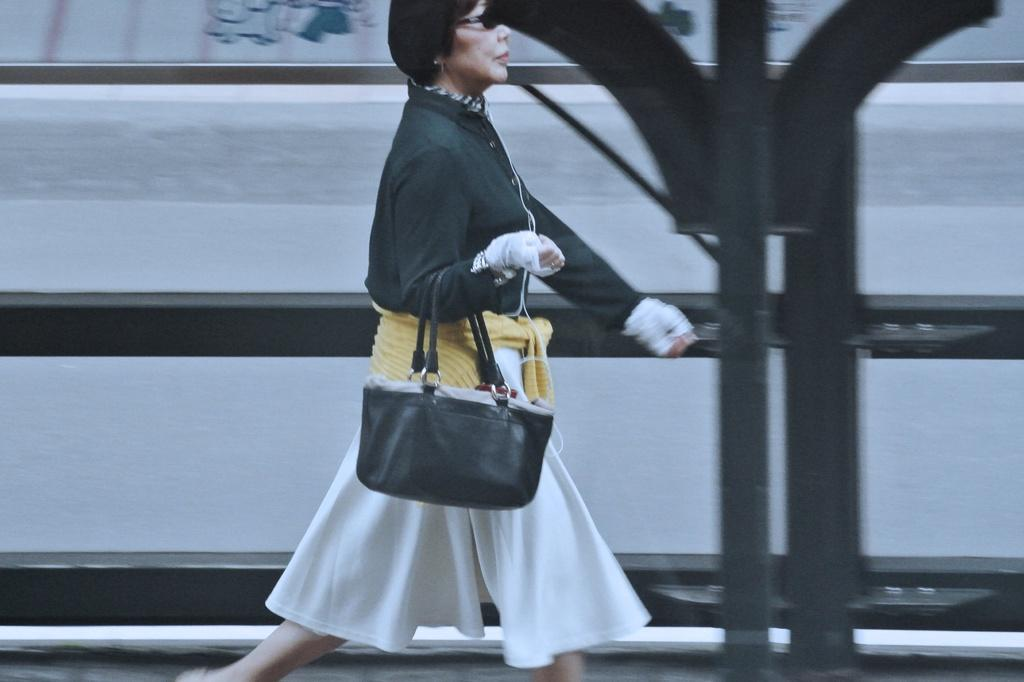Who is the main subject in the image? There is a woman in the image. What is the woman wearing? The woman is wearing a frock. What object is the woman holding? The woman is holding a handbag. What is the woman doing in the image? The woman is walking on a road. What can be seen in the background of the image? There is a fence visible in the background of the image. What type of ear is visible on the woman in the image? There is no ear visible on the woman in the image. What is the relation between the woman and the person taking the photo? The provided facts do not mention any information about the person taking the photo, so we cannot determine the relation between the woman and the photographer. 